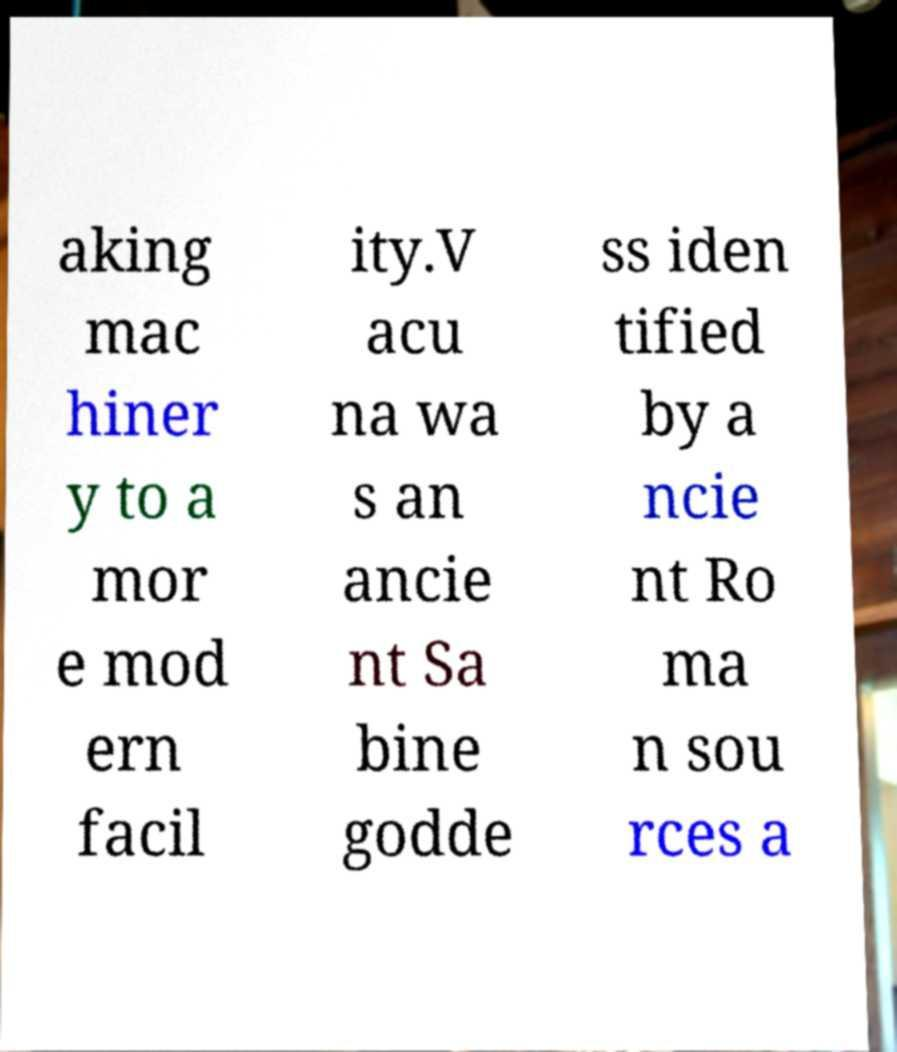I need the written content from this picture converted into text. Can you do that? aking mac hiner y to a mor e mod ern facil ity.V acu na wa s an ancie nt Sa bine godde ss iden tified by a ncie nt Ro ma n sou rces a 